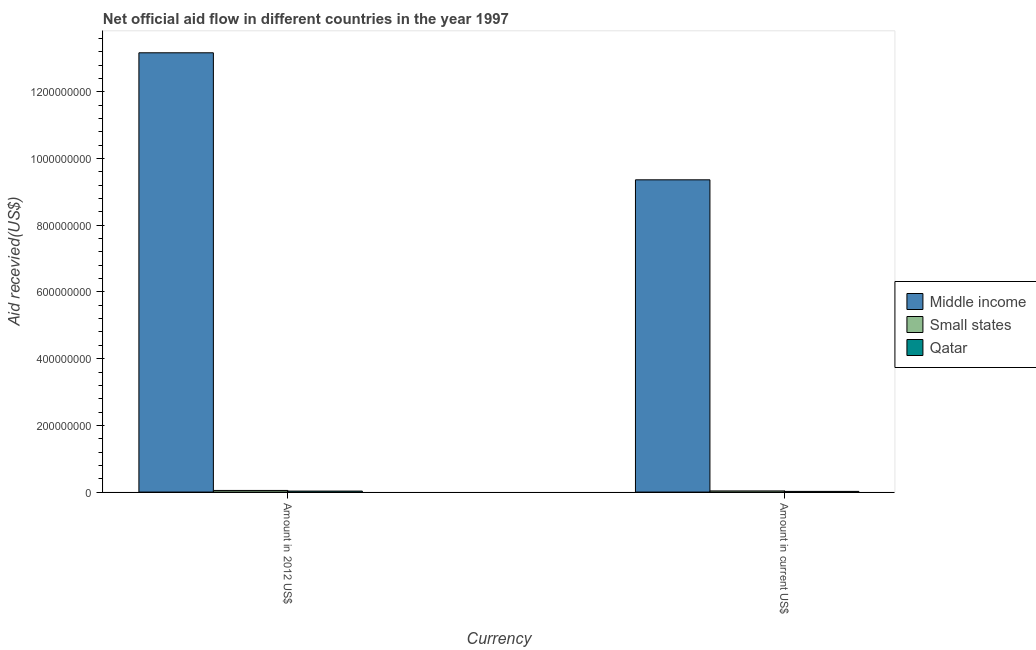How many different coloured bars are there?
Your answer should be compact. 3. Are the number of bars on each tick of the X-axis equal?
Provide a short and direct response. Yes. How many bars are there on the 2nd tick from the left?
Make the answer very short. 3. How many bars are there on the 1st tick from the right?
Ensure brevity in your answer.  3. What is the label of the 1st group of bars from the left?
Provide a succinct answer. Amount in 2012 US$. What is the amount of aid received(expressed in 2012 us$) in Middle income?
Offer a terse response. 1.32e+09. Across all countries, what is the maximum amount of aid received(expressed in us$)?
Provide a succinct answer. 9.36e+08. Across all countries, what is the minimum amount of aid received(expressed in us$)?
Your answer should be very brief. 2.06e+06. In which country was the amount of aid received(expressed in us$) maximum?
Offer a very short reply. Middle income. In which country was the amount of aid received(expressed in us$) minimum?
Ensure brevity in your answer.  Qatar. What is the total amount of aid received(expressed in us$) in the graph?
Your answer should be very brief. 9.42e+08. What is the difference between the amount of aid received(expressed in 2012 us$) in Qatar and that in Small states?
Offer a very short reply. -1.95e+06. What is the difference between the amount of aid received(expressed in 2012 us$) in Small states and the amount of aid received(expressed in us$) in Qatar?
Your response must be concise. 2.87e+06. What is the average amount of aid received(expressed in 2012 us$) per country?
Ensure brevity in your answer.  4.42e+08. What is the difference between the amount of aid received(expressed in us$) and amount of aid received(expressed in 2012 us$) in Small states?
Give a very brief answer. -1.46e+06. What is the ratio of the amount of aid received(expressed in 2012 us$) in Qatar to that in Middle income?
Ensure brevity in your answer.  0. Is the amount of aid received(expressed in 2012 us$) in Qatar less than that in Small states?
Your response must be concise. Yes. In how many countries, is the amount of aid received(expressed in us$) greater than the average amount of aid received(expressed in us$) taken over all countries?
Offer a terse response. 1. What does the 2nd bar from the left in Amount in current US$ represents?
Provide a short and direct response. Small states. What does the 2nd bar from the right in Amount in 2012 US$ represents?
Make the answer very short. Small states. How many bars are there?
Give a very brief answer. 6. How many countries are there in the graph?
Keep it short and to the point. 3. Does the graph contain any zero values?
Ensure brevity in your answer.  No. How many legend labels are there?
Make the answer very short. 3. How are the legend labels stacked?
Make the answer very short. Vertical. What is the title of the graph?
Make the answer very short. Net official aid flow in different countries in the year 1997. Does "Turkmenistan" appear as one of the legend labels in the graph?
Your answer should be very brief. No. What is the label or title of the X-axis?
Give a very brief answer. Currency. What is the label or title of the Y-axis?
Your answer should be very brief. Aid recevied(US$). What is the Aid recevied(US$) of Middle income in Amount in 2012 US$?
Provide a succinct answer. 1.32e+09. What is the Aid recevied(US$) of Small states in Amount in 2012 US$?
Your response must be concise. 4.93e+06. What is the Aid recevied(US$) of Qatar in Amount in 2012 US$?
Provide a short and direct response. 2.98e+06. What is the Aid recevied(US$) of Middle income in Amount in current US$?
Your answer should be compact. 9.36e+08. What is the Aid recevied(US$) of Small states in Amount in current US$?
Your response must be concise. 3.47e+06. What is the Aid recevied(US$) of Qatar in Amount in current US$?
Provide a short and direct response. 2.06e+06. Across all Currency, what is the maximum Aid recevied(US$) of Middle income?
Offer a very short reply. 1.32e+09. Across all Currency, what is the maximum Aid recevied(US$) of Small states?
Offer a very short reply. 4.93e+06. Across all Currency, what is the maximum Aid recevied(US$) of Qatar?
Provide a short and direct response. 2.98e+06. Across all Currency, what is the minimum Aid recevied(US$) of Middle income?
Make the answer very short. 9.36e+08. Across all Currency, what is the minimum Aid recevied(US$) of Small states?
Give a very brief answer. 3.47e+06. Across all Currency, what is the minimum Aid recevied(US$) of Qatar?
Ensure brevity in your answer.  2.06e+06. What is the total Aid recevied(US$) in Middle income in the graph?
Provide a succinct answer. 2.25e+09. What is the total Aid recevied(US$) in Small states in the graph?
Provide a succinct answer. 8.40e+06. What is the total Aid recevied(US$) of Qatar in the graph?
Provide a succinct answer. 5.04e+06. What is the difference between the Aid recevied(US$) of Middle income in Amount in 2012 US$ and that in Amount in current US$?
Provide a succinct answer. 3.81e+08. What is the difference between the Aid recevied(US$) of Small states in Amount in 2012 US$ and that in Amount in current US$?
Keep it short and to the point. 1.46e+06. What is the difference between the Aid recevied(US$) in Qatar in Amount in 2012 US$ and that in Amount in current US$?
Your response must be concise. 9.20e+05. What is the difference between the Aid recevied(US$) in Middle income in Amount in 2012 US$ and the Aid recevied(US$) in Small states in Amount in current US$?
Ensure brevity in your answer.  1.31e+09. What is the difference between the Aid recevied(US$) in Middle income in Amount in 2012 US$ and the Aid recevied(US$) in Qatar in Amount in current US$?
Offer a very short reply. 1.32e+09. What is the difference between the Aid recevied(US$) of Small states in Amount in 2012 US$ and the Aid recevied(US$) of Qatar in Amount in current US$?
Offer a very short reply. 2.87e+06. What is the average Aid recevied(US$) in Middle income per Currency?
Provide a short and direct response. 1.13e+09. What is the average Aid recevied(US$) of Small states per Currency?
Your response must be concise. 4.20e+06. What is the average Aid recevied(US$) in Qatar per Currency?
Give a very brief answer. 2.52e+06. What is the difference between the Aid recevied(US$) in Middle income and Aid recevied(US$) in Small states in Amount in 2012 US$?
Offer a very short reply. 1.31e+09. What is the difference between the Aid recevied(US$) of Middle income and Aid recevied(US$) of Qatar in Amount in 2012 US$?
Your answer should be very brief. 1.31e+09. What is the difference between the Aid recevied(US$) of Small states and Aid recevied(US$) of Qatar in Amount in 2012 US$?
Provide a short and direct response. 1.95e+06. What is the difference between the Aid recevied(US$) in Middle income and Aid recevied(US$) in Small states in Amount in current US$?
Offer a terse response. 9.33e+08. What is the difference between the Aid recevied(US$) in Middle income and Aid recevied(US$) in Qatar in Amount in current US$?
Your response must be concise. 9.34e+08. What is the difference between the Aid recevied(US$) of Small states and Aid recevied(US$) of Qatar in Amount in current US$?
Your response must be concise. 1.41e+06. What is the ratio of the Aid recevied(US$) of Middle income in Amount in 2012 US$ to that in Amount in current US$?
Provide a short and direct response. 1.41. What is the ratio of the Aid recevied(US$) of Small states in Amount in 2012 US$ to that in Amount in current US$?
Provide a short and direct response. 1.42. What is the ratio of the Aid recevied(US$) of Qatar in Amount in 2012 US$ to that in Amount in current US$?
Provide a succinct answer. 1.45. What is the difference between the highest and the second highest Aid recevied(US$) of Middle income?
Keep it short and to the point. 3.81e+08. What is the difference between the highest and the second highest Aid recevied(US$) of Small states?
Provide a succinct answer. 1.46e+06. What is the difference between the highest and the second highest Aid recevied(US$) in Qatar?
Provide a short and direct response. 9.20e+05. What is the difference between the highest and the lowest Aid recevied(US$) in Middle income?
Your answer should be compact. 3.81e+08. What is the difference between the highest and the lowest Aid recevied(US$) in Small states?
Your answer should be very brief. 1.46e+06. What is the difference between the highest and the lowest Aid recevied(US$) of Qatar?
Give a very brief answer. 9.20e+05. 